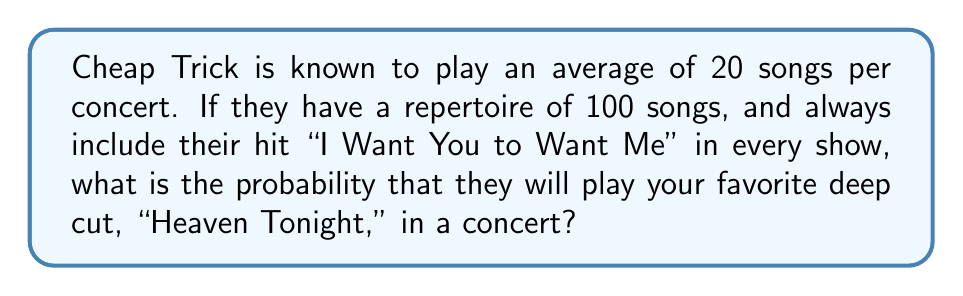Can you solve this math problem? To solve this problem, we need to use the concept of probability and consider the following steps:

1. We know that Cheap Trick plays 20 songs per concert.
2. One of these songs is always "I Want You to Want Me."
3. This leaves 19 slots for other songs.
4. The band has a total of 100 songs in their repertoire.
5. "I Want You to Want Me" and "Heaven Tonight" are 2 of these 100 songs.

Now, let's calculate the probability:

1. The number of remaining songs in the repertoire:
   $100 - 2 = 98$ songs (excluding "I Want You to Want Me" and "Heaven Tonight")

2. The probability of "Heaven Tonight" being selected for any one of the 19 remaining slots is:
   $P(\text{Heaven Tonight}) = \frac{1}{98}$

3. The probability of "Heaven Tonight" not being selected for a single slot is:
   $P(\text{Not Heaven Tonight}) = 1 - \frac{1}{98} = \frac{97}{98}$

4. The probability of "Heaven Tonight" not being selected for any of the 19 slots is:
   $P(\text{Not Heaven Tonight in 19 slots}) = (\frac{97}{98})^{19}$

5. Therefore, the probability of "Heaven Tonight" being played in the concert is:
   $$P(\text{Heaven Tonight played}) = 1 - (\frac{97}{98})^{19}$$

6. Calculating this value:
   $$1 - (\frac{97}{98})^{19} \approx 0.1767$$
Answer: The probability of hearing "Heaven Tonight" at a Cheap Trick concert is approximately 0.1767 or 17.67%. 